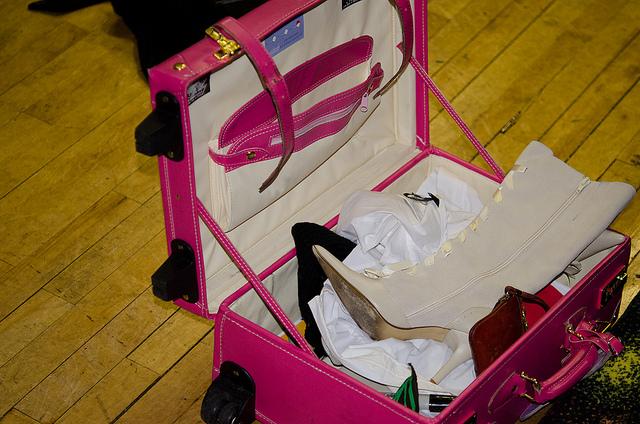Where are the wheels?
Write a very short answer. Left side. What is brown?
Concise answer only. Floor. What is the pattern of the liner on the top inside of the box?
Be succinct. Plain. What is the color of the suitcase?
Give a very brief answer. Pink. How many pink storage bins are there?
Answer briefly. 1. What color are the suitcases?
Answer briefly. Pink. What's for the dog?
Concise answer only. Nothing. What's the pink object?
Keep it brief. Suitcase. What color is the container?
Short answer required. Pink. Is this a junk pile?
Give a very brief answer. No. What color is the outside of this luggage?
Answer briefly. Pink. What type of shoe is pictured?
Give a very brief answer. Boot. What shade of blue is that luggage?
Quick response, please. Pink. Is this a farmers market?
Be succinct. No. Is a doll in the suitcase?
Give a very brief answer. No. What kind of floor is it?
Answer briefly. Wood. Were the arrows shot in this room?
Keep it brief. No. What is in the suitcase?
Short answer required. Boot. Is the suitcase full?
Be succinct. Yes. What color is the suitcase?
Write a very short answer. Pink. 